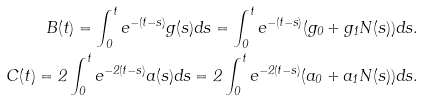Convert formula to latex. <formula><loc_0><loc_0><loc_500><loc_500>B ( t ) = \int _ { 0 } ^ { t } e ^ { - ( t - s ) } g ( s ) d s = \int _ { 0 } ^ { t } e ^ { - ( t - s ) } ( g _ { 0 } + g _ { 1 } N ( s ) ) d s . \\ C ( t ) = 2 \int _ { 0 } ^ { t } e ^ { - 2 ( t - s ) } a ( s ) d s = 2 \int _ { 0 } ^ { t } e ^ { - 2 ( t - s ) } ( a _ { 0 } + a _ { 1 } N ( s ) ) d s .</formula> 